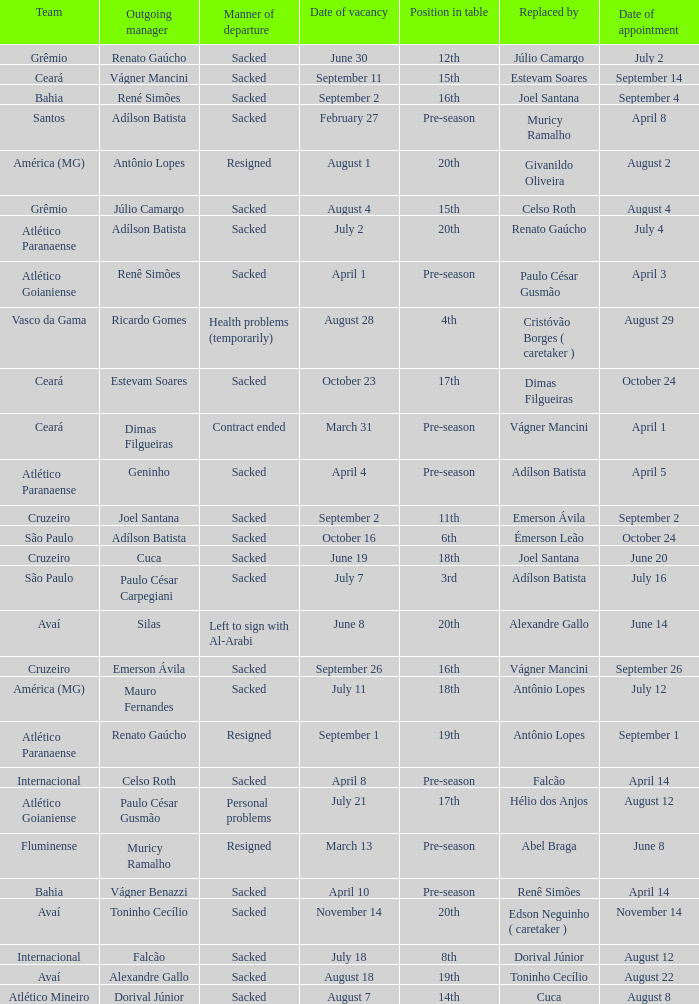Who was replaced as manager on June 20? Cuca. 